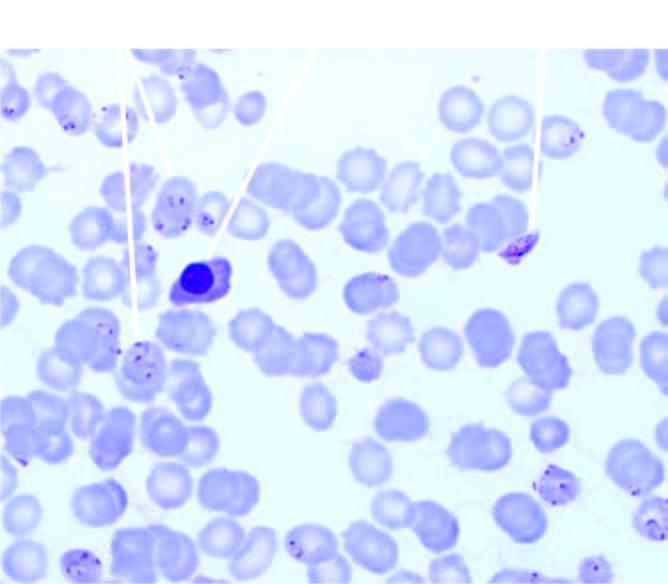what does the background show?
Answer the question using a single word or phrase. A normoblast 